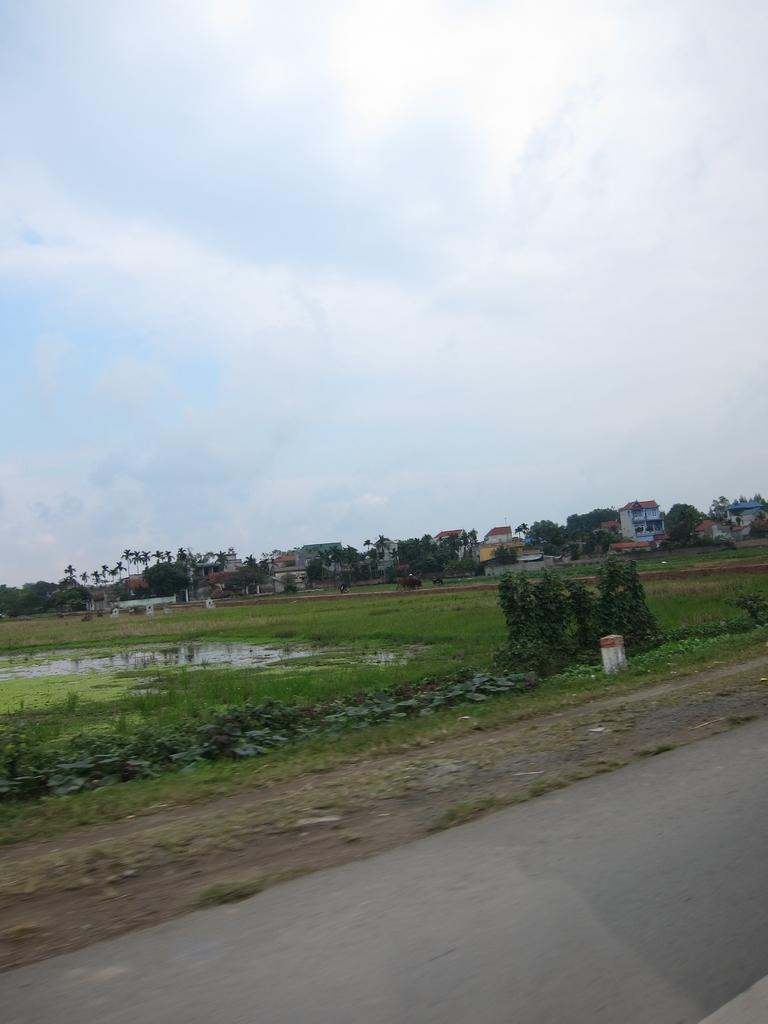What type of vegetation can be seen in the image? There are plants and trees visible in the image. What is the primary element present in the image? Water is visible in the image. What type of structures can be seen in the image? There are houses in the image. What is visible behind the houses? The sky is visible behind the houses. What is the road's location in relation to the plants? There is a road in front of the plants. Can you see any goldfish swimming in the water in the image? There are no goldfish visible in the image; only plants, trees, houses, and a road are present. Is there an island in the image? There is no island present in the image. 